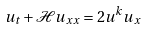<formula> <loc_0><loc_0><loc_500><loc_500>u _ { t } + \mathcal { H } u _ { x x } = 2 u ^ { k } u _ { x }</formula> 